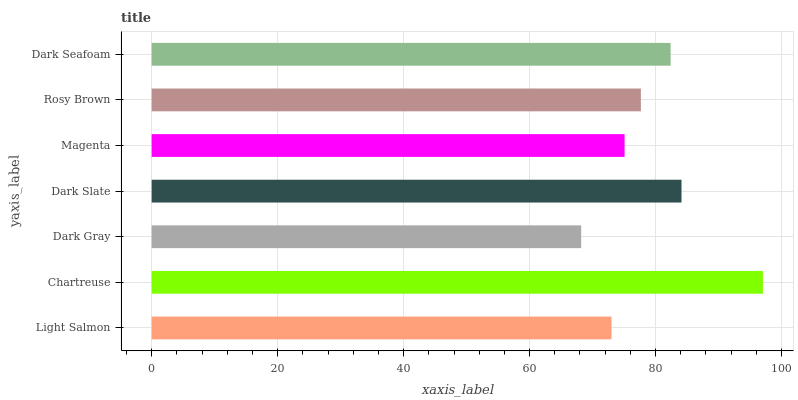Is Dark Gray the minimum?
Answer yes or no. Yes. Is Chartreuse the maximum?
Answer yes or no. Yes. Is Chartreuse the minimum?
Answer yes or no. No. Is Dark Gray the maximum?
Answer yes or no. No. Is Chartreuse greater than Dark Gray?
Answer yes or no. Yes. Is Dark Gray less than Chartreuse?
Answer yes or no. Yes. Is Dark Gray greater than Chartreuse?
Answer yes or no. No. Is Chartreuse less than Dark Gray?
Answer yes or no. No. Is Rosy Brown the high median?
Answer yes or no. Yes. Is Rosy Brown the low median?
Answer yes or no. Yes. Is Dark Slate the high median?
Answer yes or no. No. Is Dark Seafoam the low median?
Answer yes or no. No. 